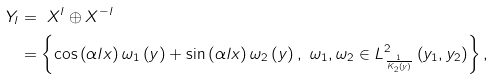<formula> <loc_0><loc_0><loc_500><loc_500>Y _ { l } & = \ X ^ { l } \oplus X ^ { - l } \\ & = \left \{ \cos \left ( \alpha l x \right ) \omega _ { 1 } \left ( y \right ) + \sin \left ( \alpha l x \right ) \omega _ { 2 } \left ( y \right ) , \ \omega _ { 1 } , \omega _ { 2 } \in L _ { \frac { 1 } { K _ { 2 } \left ( y \right ) } } ^ { 2 } \left ( y _ { 1 } , y _ { 2 } \right ) \right \} ,</formula> 